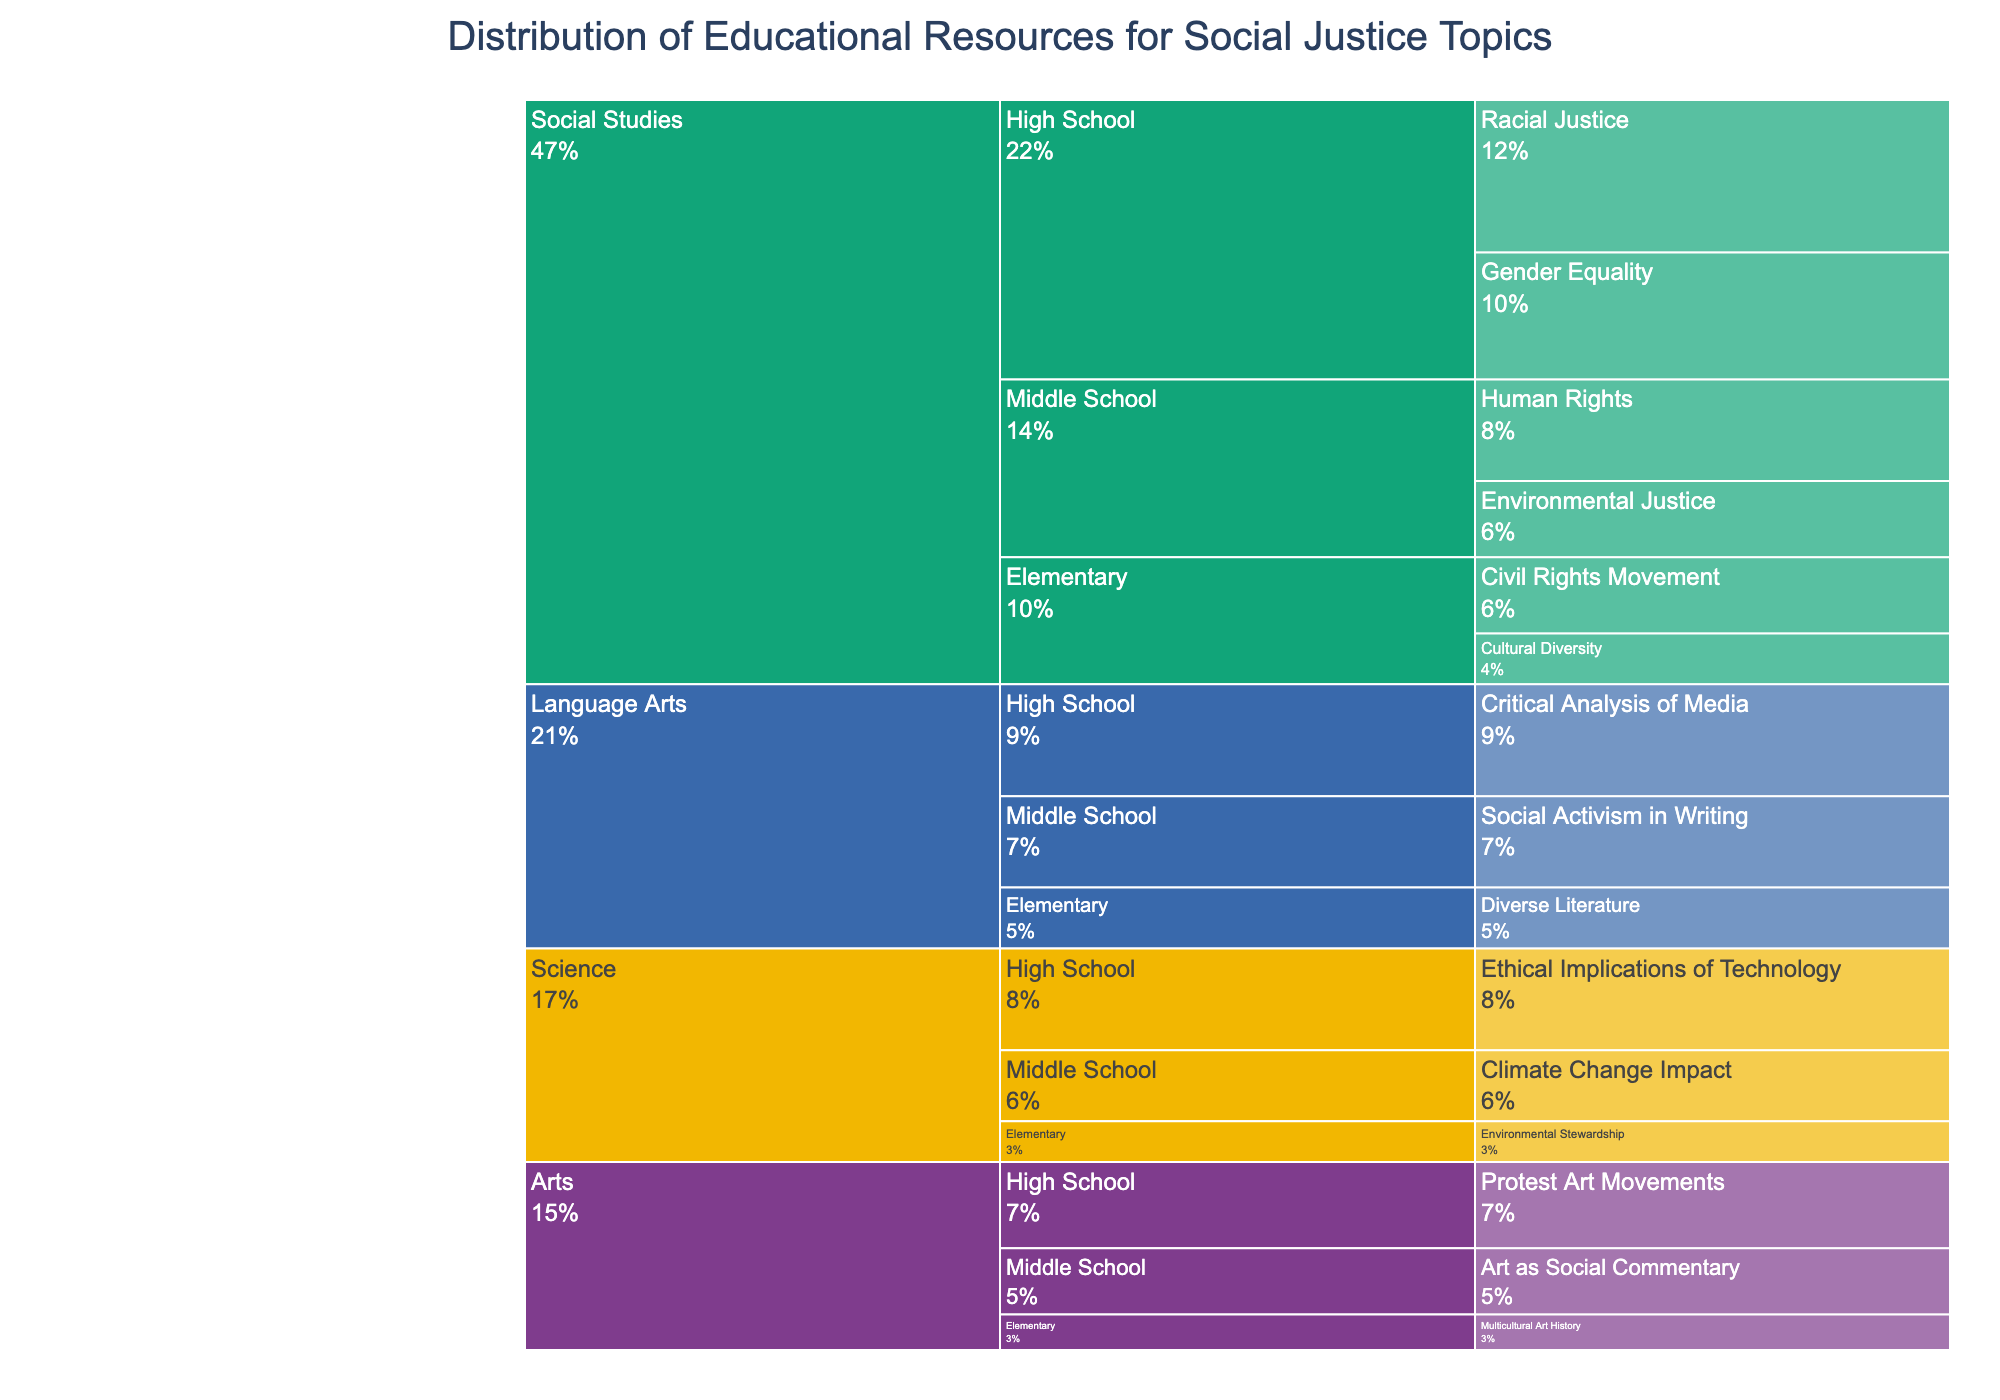What's the title of the Icicle Chart? The title is displayed at the top of the chart.
Answer: Distribution of Educational Resources for Social Justice Topics Which subject received the highest total allocation for social justice topics at the high school level? Look at the high school level and compare the allocations for each subject. Social Studies has the highest total allocation.
Answer: Social Studies What is the total allocation percentage for social studies topics in elementary school? Add the percentages for Civil Rights Movement (15) and Cultural Diversity (10). The total is 15 + 10 = 25%.
Answer: 25% How does the allocation for Gender Equality in high school compare to that for Critical Analysis of Media in high school? Identify the allocations for each topic. Gender Equality has 25% and Critical Analysis of Media has 22%. The former is higher.
Answer: Gender Equality has a higher allocation Which topic in middle school Science receives the most resources? Compare the allocations for Climate Change Impact (14) and any other topics listed.
Answer: Climate Change Impact What is the combined allocation for Environmental Justice and Racial Justice across all grade levels? Add the percentages for Environmental Justice (15) and Racial Justice (30). The total is 15 + 30 = 45%.
Answer: 45% What percentage of the entire resources allocated to Language Arts in elementary grade is dedicated to Diverse Literature? Look at the segment for Diverse Literature under Language Arts in the elementary grade. It is 12%.
Answer: 12% Compare the allocations for art topics between middle and high school. Which level receives more resources in total? Sum the allocations for Art as Social Commentary (13) and Protest Art Movements (17). Middle school: 13%, High school: 17%. High school receives more resources.
Answer: High school Which subject has the smallest allocation of resources at the elementary level? Compare the smallest allocation percentages in the elementary categories. Arts have the smallest with Multicultural Art History at 7%.
Answer: Arts Is the allocation for Environmental Stewardship in elementary Science higher or lower than Multicultural Art History in elementary Arts? Compare 8% for Environmental Stewardship to 7% for Multicultural Art History. Environmental Stewardship is higher.
Answer: Higher 